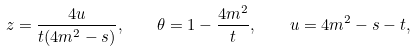Convert formula to latex. <formula><loc_0><loc_0><loc_500><loc_500>z = \frac { 4 u } { t ( 4 m ^ { 2 } - s ) } , \quad \theta = 1 - \frac { 4 m ^ { 2 } } { t } , \quad u = 4 m ^ { 2 } - s - t ,</formula> 